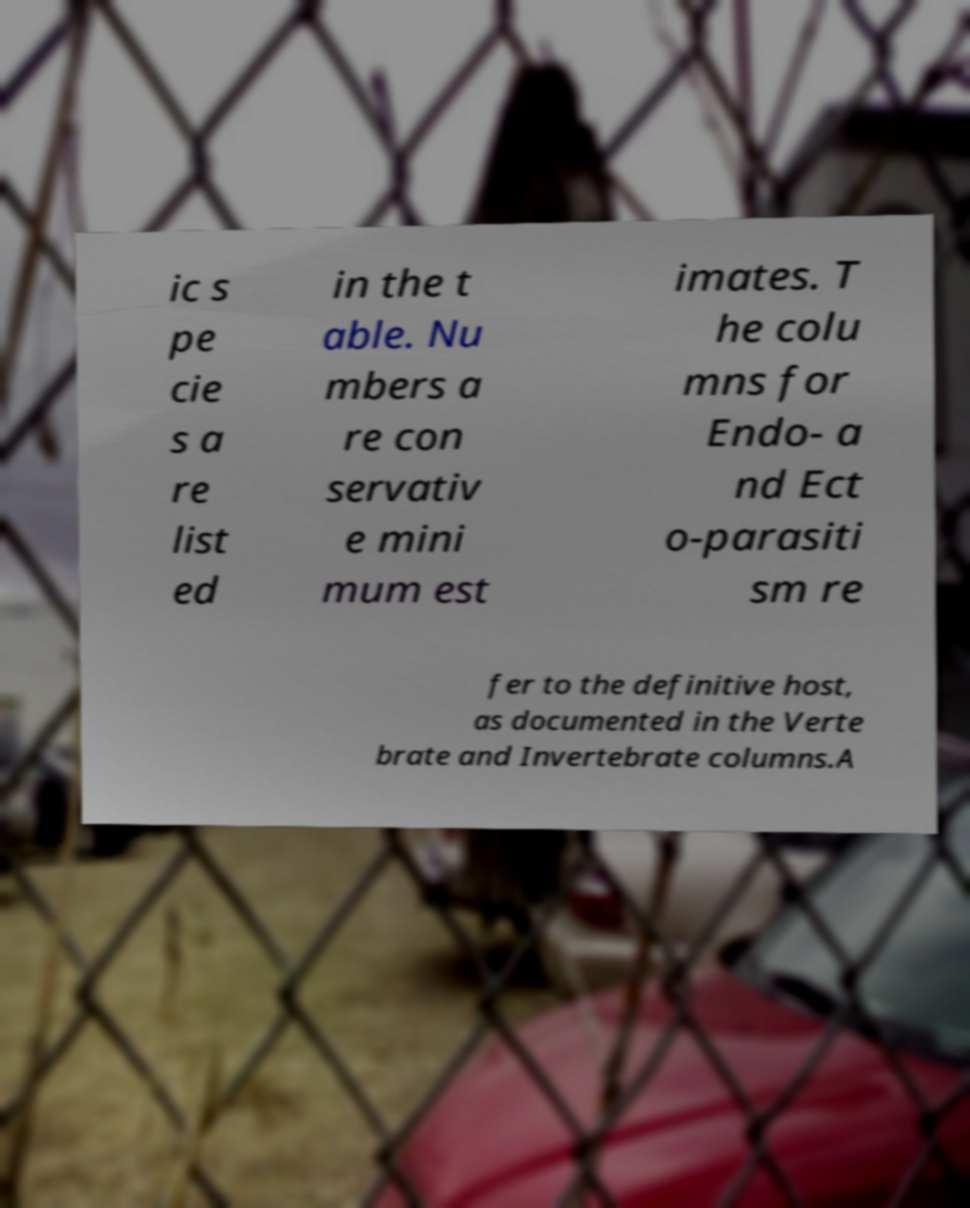Please read and relay the text visible in this image. What does it say? ic s pe cie s a re list ed in the t able. Nu mbers a re con servativ e mini mum est imates. T he colu mns for Endo- a nd Ect o-parasiti sm re fer to the definitive host, as documented in the Verte brate and Invertebrate columns.A 